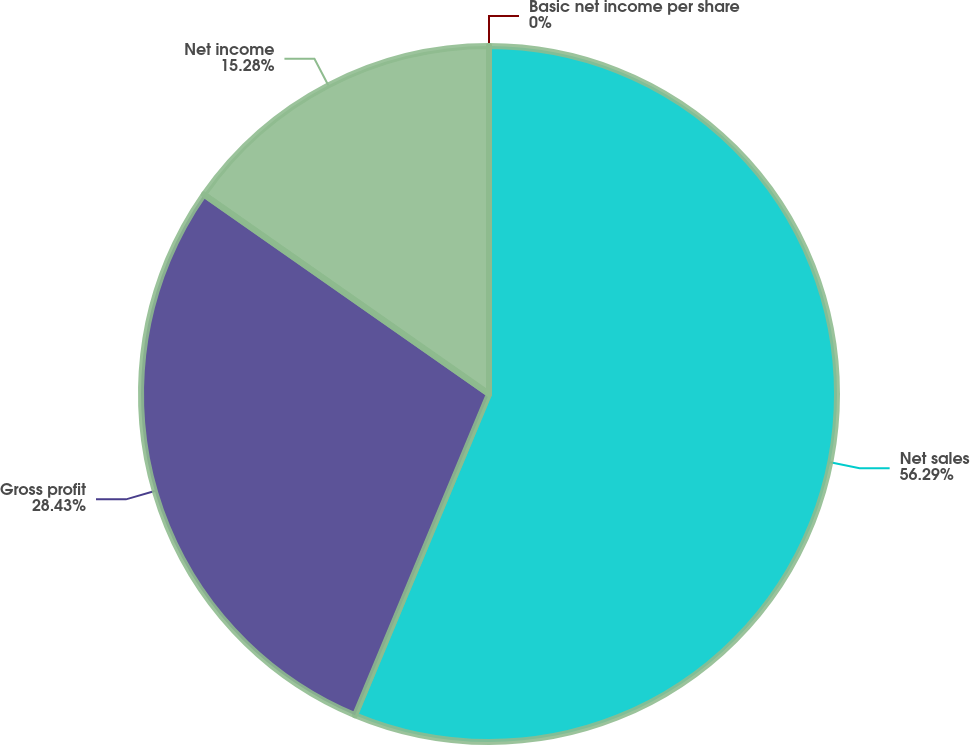Convert chart. <chart><loc_0><loc_0><loc_500><loc_500><pie_chart><fcel>Net sales<fcel>Gross profit<fcel>Net income<fcel>Basic net income per share<nl><fcel>56.29%<fcel>28.43%<fcel>15.28%<fcel>0.0%<nl></chart> 